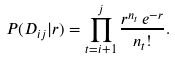Convert formula to latex. <formula><loc_0><loc_0><loc_500><loc_500>P ( D _ { i j } | r ) = \prod _ { t = i + 1 } ^ { j } \frac { r ^ { n _ { t } } \, e ^ { - r } } { n _ { t } ! } .</formula> 